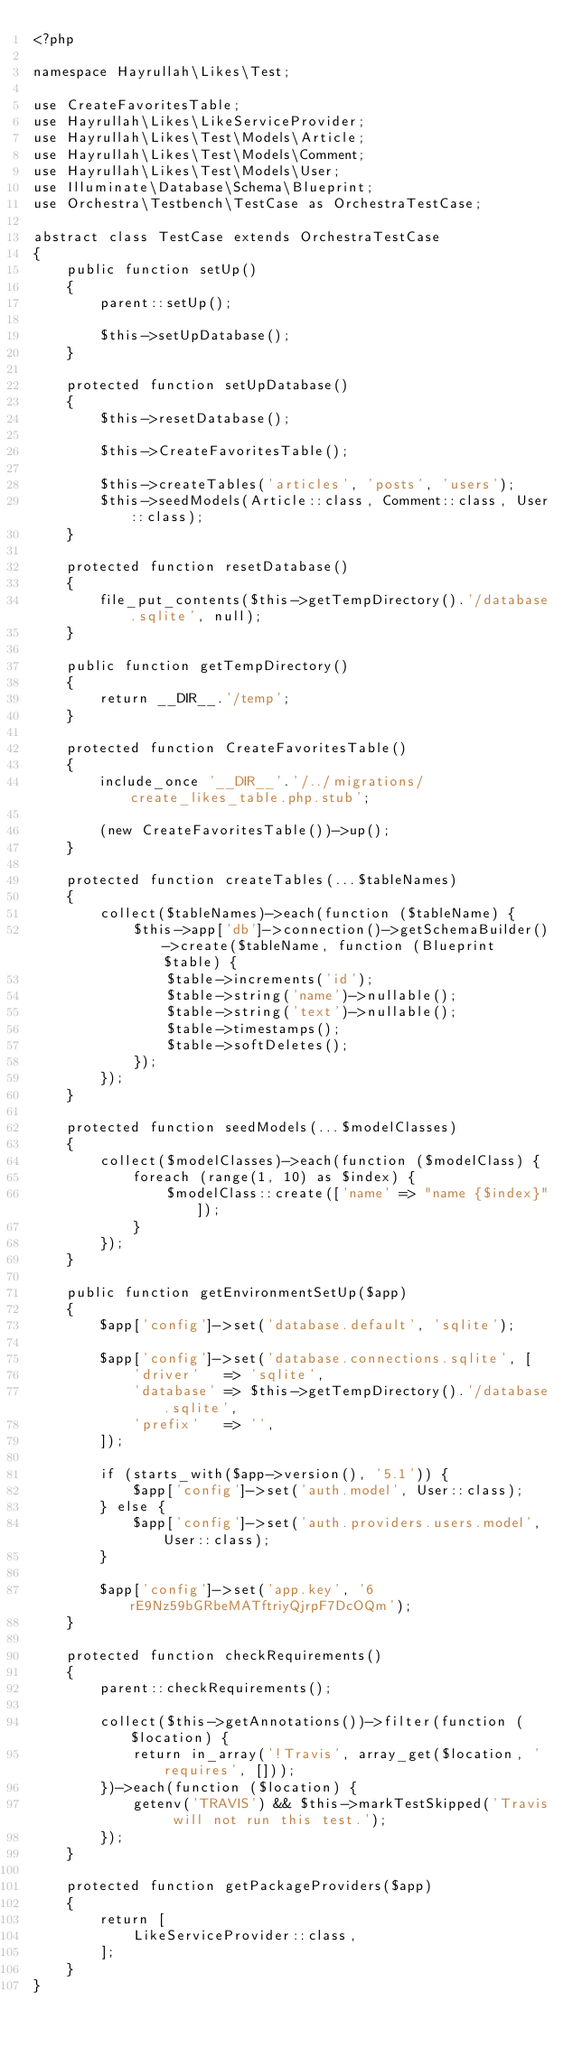Convert code to text. <code><loc_0><loc_0><loc_500><loc_500><_PHP_><?php

namespace Hayrullah\Likes\Test;

use CreateFavoritesTable;
use Hayrullah\Likes\LikeServiceProvider;
use Hayrullah\Likes\Test\Models\Article;
use Hayrullah\Likes\Test\Models\Comment;
use Hayrullah\Likes\Test\Models\User;
use Illuminate\Database\Schema\Blueprint;
use Orchestra\Testbench\TestCase as OrchestraTestCase;

abstract class TestCase extends OrchestraTestCase
{
    public function setUp()
    {
        parent::setUp();

        $this->setUpDatabase();
    }

    protected function setUpDatabase()
    {
        $this->resetDatabase();

        $this->CreateFavoritesTable();

        $this->createTables('articles', 'posts', 'users');
        $this->seedModels(Article::class, Comment::class, User::class);
    }

    protected function resetDatabase()
    {
        file_put_contents($this->getTempDirectory().'/database.sqlite', null);
    }

    public function getTempDirectory()
    {
        return __DIR__.'/temp';
    }

    protected function CreateFavoritesTable()
    {
        include_once '__DIR__'.'/../migrations/create_likes_table.php.stub';

        (new CreateFavoritesTable())->up();
    }

    protected function createTables(...$tableNames)
    {
        collect($tableNames)->each(function ($tableName) {
            $this->app['db']->connection()->getSchemaBuilder()->create($tableName, function (Blueprint $table) {
                $table->increments('id');
                $table->string('name')->nullable();
                $table->string('text')->nullable();
                $table->timestamps();
                $table->softDeletes();
            });
        });
    }

    protected function seedModels(...$modelClasses)
    {
        collect($modelClasses)->each(function ($modelClass) {
            foreach (range(1, 10) as $index) {
                $modelClass::create(['name' => "name {$index}"]);
            }
        });
    }

    public function getEnvironmentSetUp($app)
    {
        $app['config']->set('database.default', 'sqlite');

        $app['config']->set('database.connections.sqlite', [
            'driver'   => 'sqlite',
            'database' => $this->getTempDirectory().'/database.sqlite',
            'prefix'   => '',
        ]);

        if (starts_with($app->version(), '5.1')) {
            $app['config']->set('auth.model', User::class);
        } else {
            $app['config']->set('auth.providers.users.model', User::class);
        }

        $app['config']->set('app.key', '6rE9Nz59bGRbeMATftriyQjrpF7DcOQm');
    }

    protected function checkRequirements()
    {
        parent::checkRequirements();

        collect($this->getAnnotations())->filter(function ($location) {
            return in_array('!Travis', array_get($location, 'requires', []));
        })->each(function ($location) {
            getenv('TRAVIS') && $this->markTestSkipped('Travis will not run this test.');
        });
    }

    protected function getPackageProviders($app)
    {
        return [
            LikeServiceProvider::class,
        ];
    }
}
</code> 